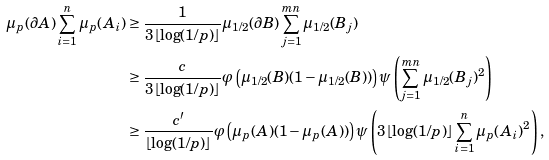Convert formula to latex. <formula><loc_0><loc_0><loc_500><loc_500>\mu _ { p } ( \partial A ) \sum _ { i = 1 } ^ { n } \mu _ { p } ( A _ { i } ) & \geq \frac { 1 } { 3 \lfloor \log ( 1 / p ) \rfloor } \mu _ { 1 / 2 } ( \partial B ) \sum _ { j = 1 } ^ { m n } \mu _ { 1 / 2 } ( B _ { j } ) \\ & \geq \frac { c } { 3 \lfloor \log ( 1 / p ) \rfloor } \varphi \left ( \mu _ { 1 / 2 } ( B ) ( 1 - \mu _ { 1 / 2 } ( B ) ) \right ) \psi \left ( \sum _ { j = 1 } ^ { m n } \mu _ { 1 / 2 } ( B _ { j } ) ^ { 2 } \right ) \\ & \geq \frac { c ^ { \prime } } { \lfloor \log ( 1 / p ) \rfloor } \varphi \left ( \mu _ { p } ( A ) ( 1 - \mu _ { p } ( A ) ) \right ) \psi \left ( 3 \lfloor \log ( 1 / p ) \rfloor \sum _ { i = 1 } ^ { n } \mu _ { p } ( A _ { i } ) ^ { 2 } \right ) ,</formula> 